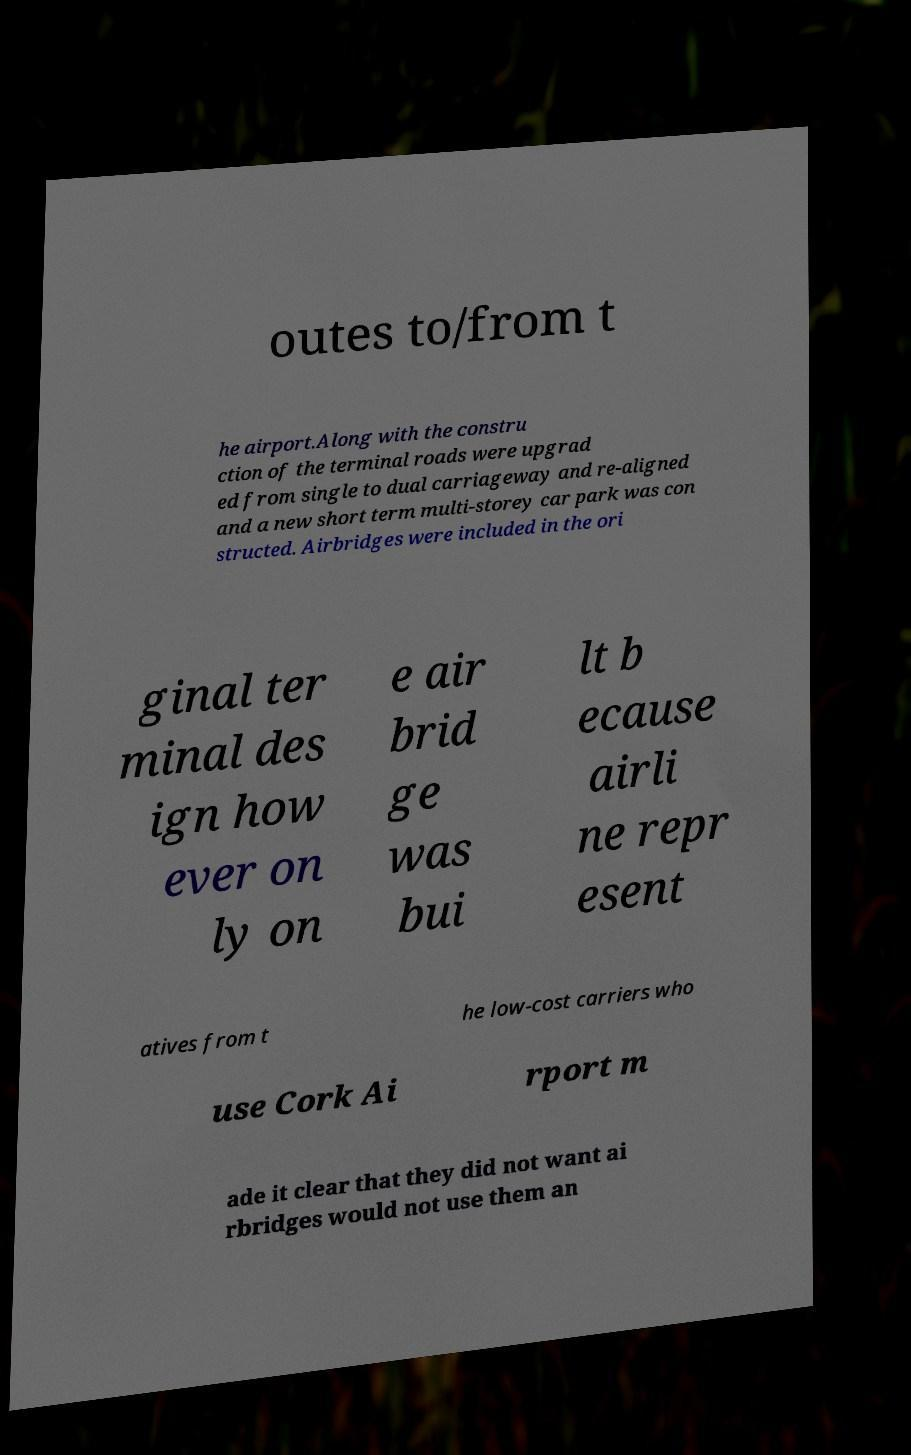Please identify and transcribe the text found in this image. outes to/from t he airport.Along with the constru ction of the terminal roads were upgrad ed from single to dual carriageway and re-aligned and a new short term multi-storey car park was con structed. Airbridges were included in the ori ginal ter minal des ign how ever on ly on e air brid ge was bui lt b ecause airli ne repr esent atives from t he low-cost carriers who use Cork Ai rport m ade it clear that they did not want ai rbridges would not use them an 